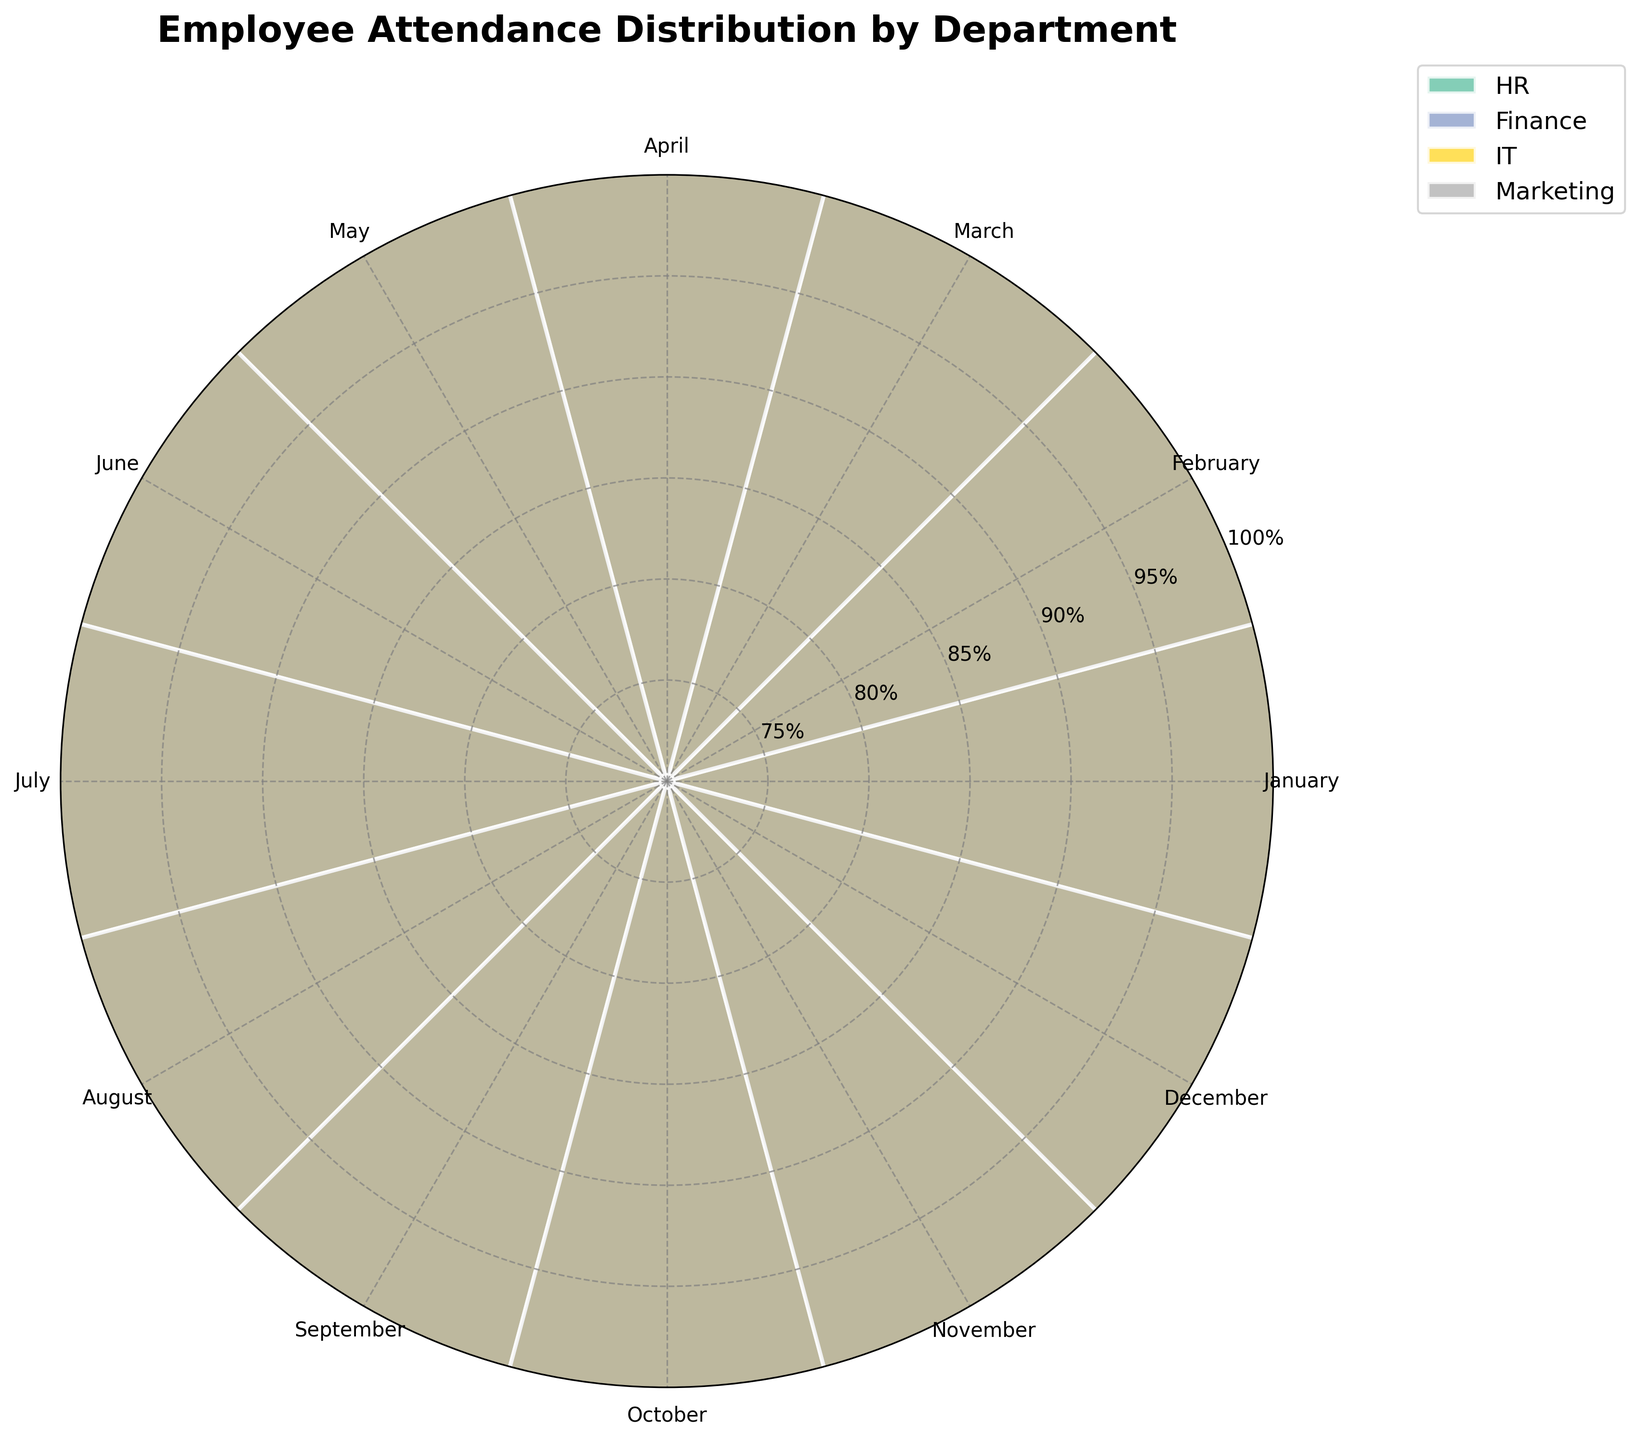What is the title of the chart? The title is displayed prominently at the top of the chart. It reads "Employee Attendance Distribution by Department."
Answer: Employee Attendance Distribution by Department How many departments are represented in the chart? Each color bar on the chart represents a different department. By counting the distinct color bars, we find four departments are represented.
Answer: 4 Which department has the highest attendance percentage in March? Locate the radial section for March, and observe the heights of the bars within that section. The IT department's bar is the tallest for March.
Answer: IT Which department shows the most fluctuation in attendance percentage throughout the year? Compare the range of heights of the bars for each department across all months. The Marketing department shows the most variation, with attendance percentages from 80% to 83%.
Answer: Marketing What's the average attendance percentage for the HR department? Sum the HR attendance percentages for each month and divide by 12: (88 + 90 + 92 + 89 + 91 + 87 + 90 + 92 + 88 + 91 + 89 + 90) / 12 = 90.0.
Answer: 90% Is any department's attendance above 90% for all months? Check each month's bar for values above 90% for any department. The IT department consistently has attendance percentages above 90% for all months except for August and January when it is 90%.
Answer: No In which month does the Finance department have the lowest attendance percentage? Look at the heights of the bars for the Finance department across all months. The bar is shortest in November, indicating the lowest attendance of 85%.
Answer: November Which department has the most consistent attendance, and what is the range of its attendance percentages? Consistency is reflected by a narrow range of values. For the HR department, the attendance percentages vary from 87% to 92%, giving it a range of 5%.
Answer: HR, 5% How does the average attendance of the Marketing department compare with that of the IT department for January? The Marketing department has an attendance of 80% in January, while the IT department has 90%. 90% is higher than 80%.
Answer: IT's attendance is higher by 10% Is the overall attendance trend for the HR department increasing, decreasing, or stable over the year? Observe the general pattern of the HR department's bar heights over the months. The attendance percentages fluctuate but generally remain stable around 88-92%.
Answer: Stable 